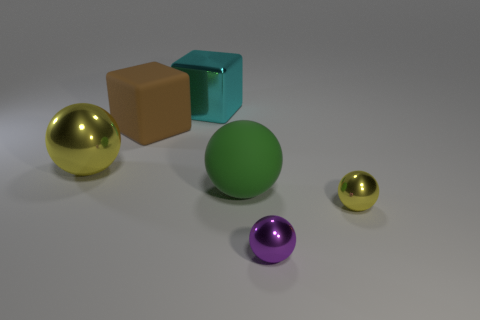Are there fewer yellow spheres on the left side of the large rubber sphere than large green rubber balls?
Ensure brevity in your answer.  No. The tiny shiny thing in front of the yellow thing on the right side of the big matte thing in front of the large brown object is what color?
Make the answer very short. Purple. There is a purple thing that is the same shape as the small yellow thing; what size is it?
Provide a succinct answer. Small. Is the number of objects right of the tiny yellow metallic ball less than the number of purple spheres behind the cyan object?
Your response must be concise. No. There is a object that is both behind the big yellow shiny sphere and in front of the big cyan thing; what shape is it?
Offer a very short reply. Cube. The cyan cube that is the same material as the tiny purple ball is what size?
Offer a very short reply. Large. There is a big metallic ball; is it the same color as the tiny sphere behind the tiny purple shiny thing?
Your answer should be compact. Yes. There is a large thing that is both to the right of the big brown thing and in front of the big cyan metallic cube; what material is it made of?
Ensure brevity in your answer.  Rubber. There is a yellow metallic thing that is on the left side of the big cyan object; is it the same shape as the matte thing to the left of the rubber sphere?
Keep it short and to the point. No. Is there a green sphere?
Provide a succinct answer. Yes. 